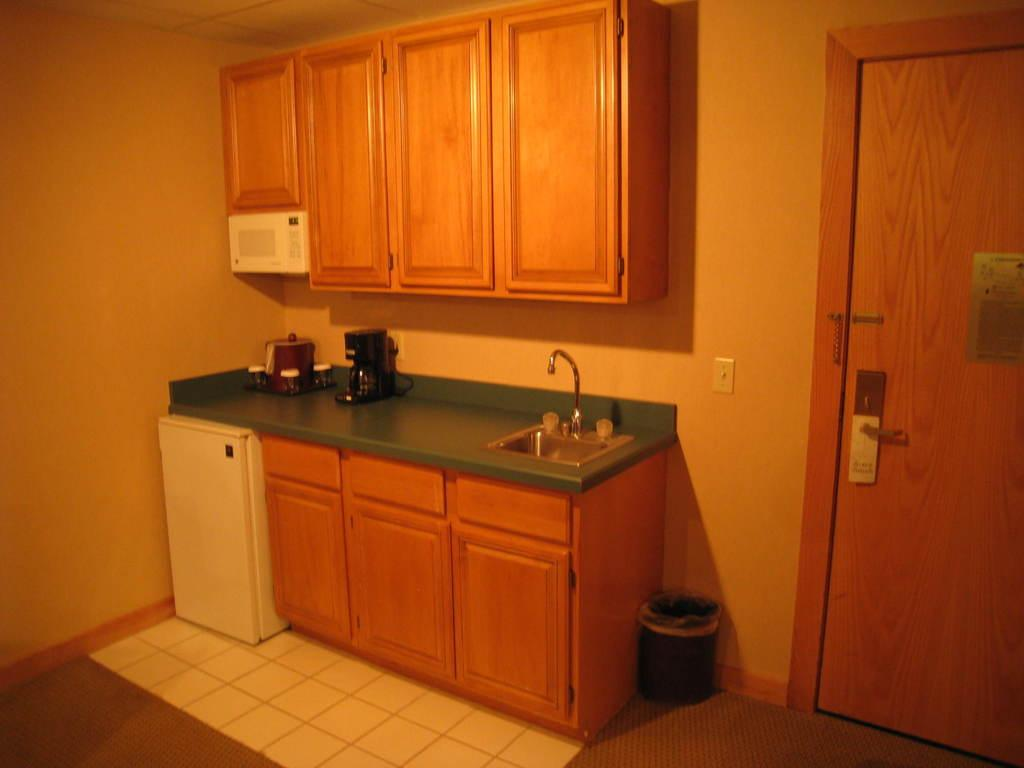What surface is located at the bottom of the image? There is a kitchen countertop at the bottom of the image. What can be seen in the background of the image? There is a wall in the background of the image. What type of container is present at the bottom of the image? There is a dustbin at the bottom of the image. What type of coal is stored in the dustbin in the image? There is no coal present in the image; it features a kitchen countertop, a wall, and a dustbin. How many deer can be seen grazing on the kitchen countertop in the image? There are no deer present in the image; it only features a kitchen countertop, a wall, and a dustbin. 